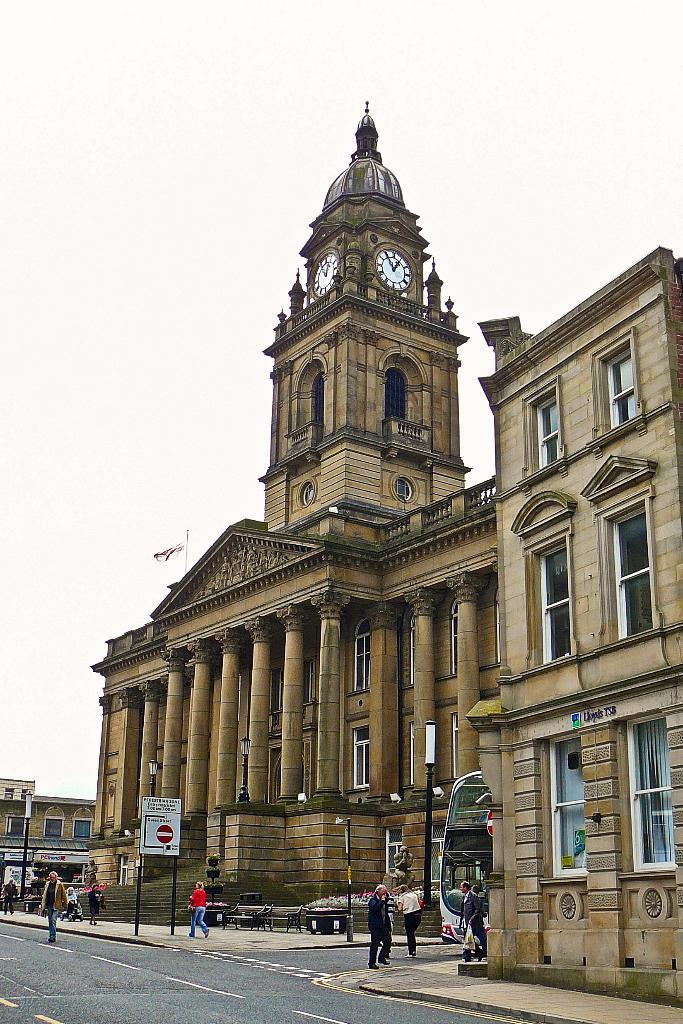What type of building is located on the left side of the image? There is a palace on the left side of the image. What feature is present above the palace? The palace has a clock tower above it. What can be seen in front of the palace? There are people walking on a footpath in front of the palace. What is located beside the palace? There is a road beside the palace. What is visible above the palace and the surrounding area? The sky is visible above the palace. What type of hat is the rail wearing in the image? There is no rail or hat present in the image. 